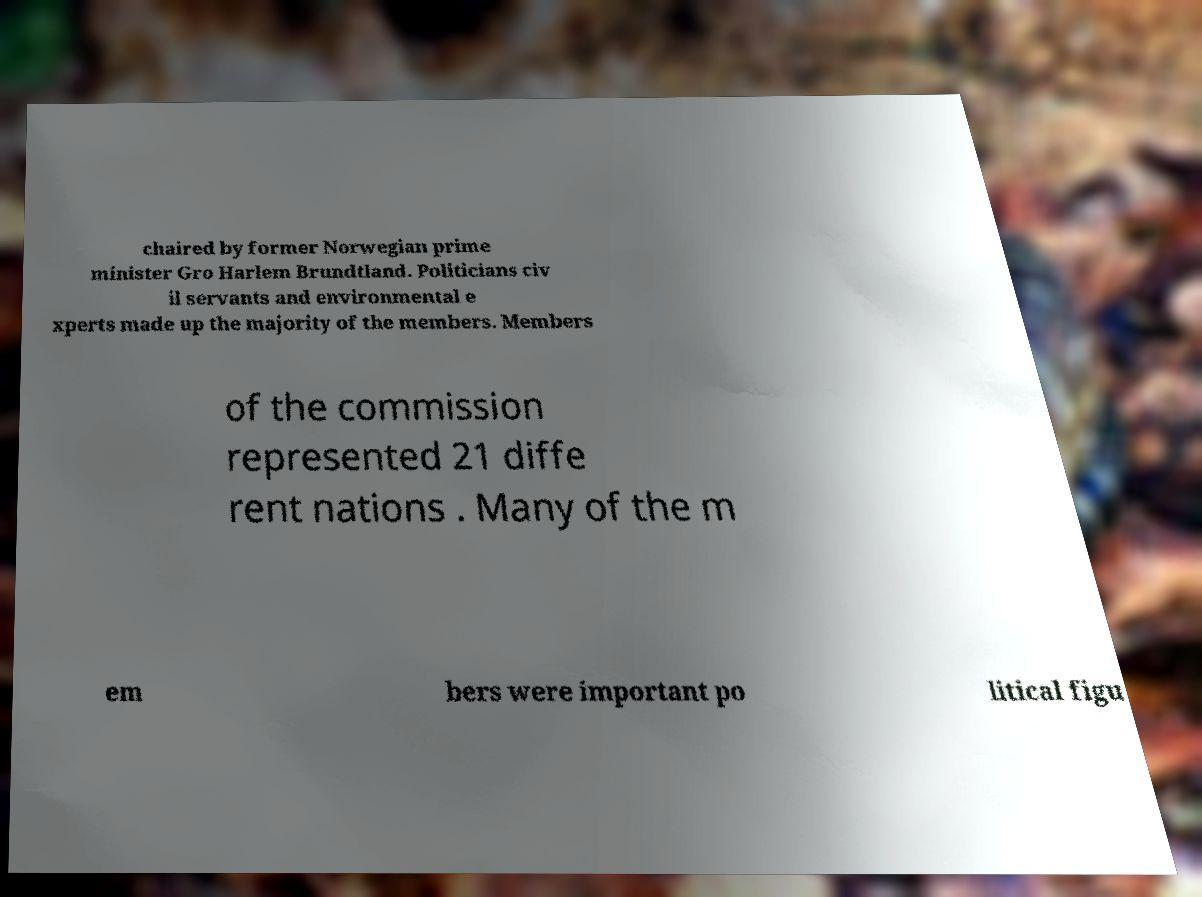There's text embedded in this image that I need extracted. Can you transcribe it verbatim? chaired by former Norwegian prime minister Gro Harlem Brundtland. Politicians civ il servants and environmental e xperts made up the majority of the members. Members of the commission represented 21 diffe rent nations . Many of the m em bers were important po litical figu 